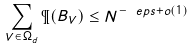<formula> <loc_0><loc_0><loc_500><loc_500>\sum _ { V \in \Omega _ { d } } \P ( B _ { V } ) \leq N ^ { - \ e p s + o ( 1 ) }</formula> 